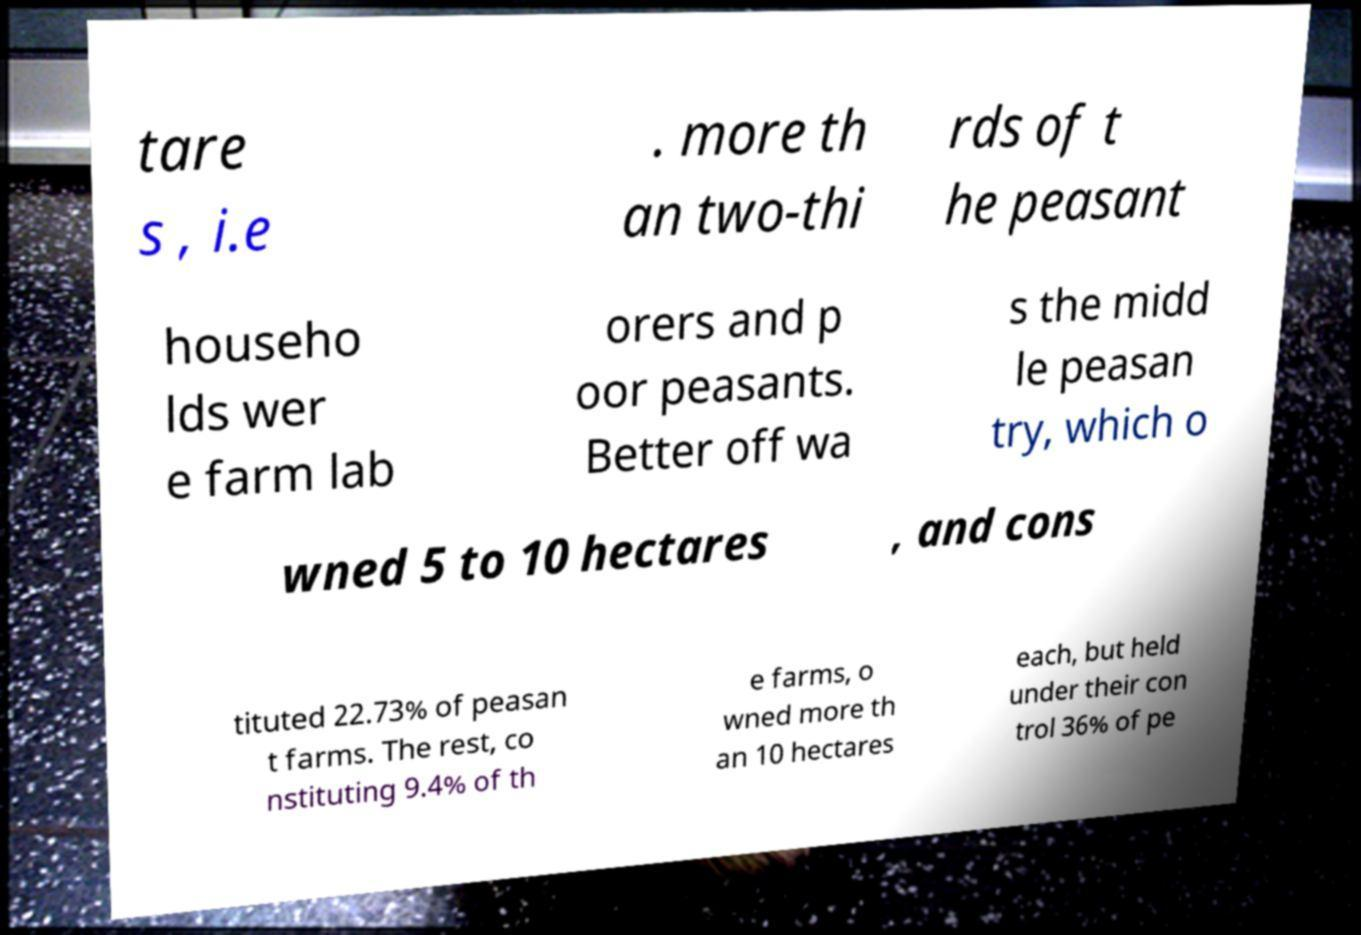Can you accurately transcribe the text from the provided image for me? tare s , i.e . more th an two-thi rds of t he peasant househo lds wer e farm lab orers and p oor peasants. Better off wa s the midd le peasan try, which o wned 5 to 10 hectares , and cons tituted 22.73% of peasan t farms. The rest, co nstituting 9.4% of th e farms, o wned more th an 10 hectares each, but held under their con trol 36% of pe 